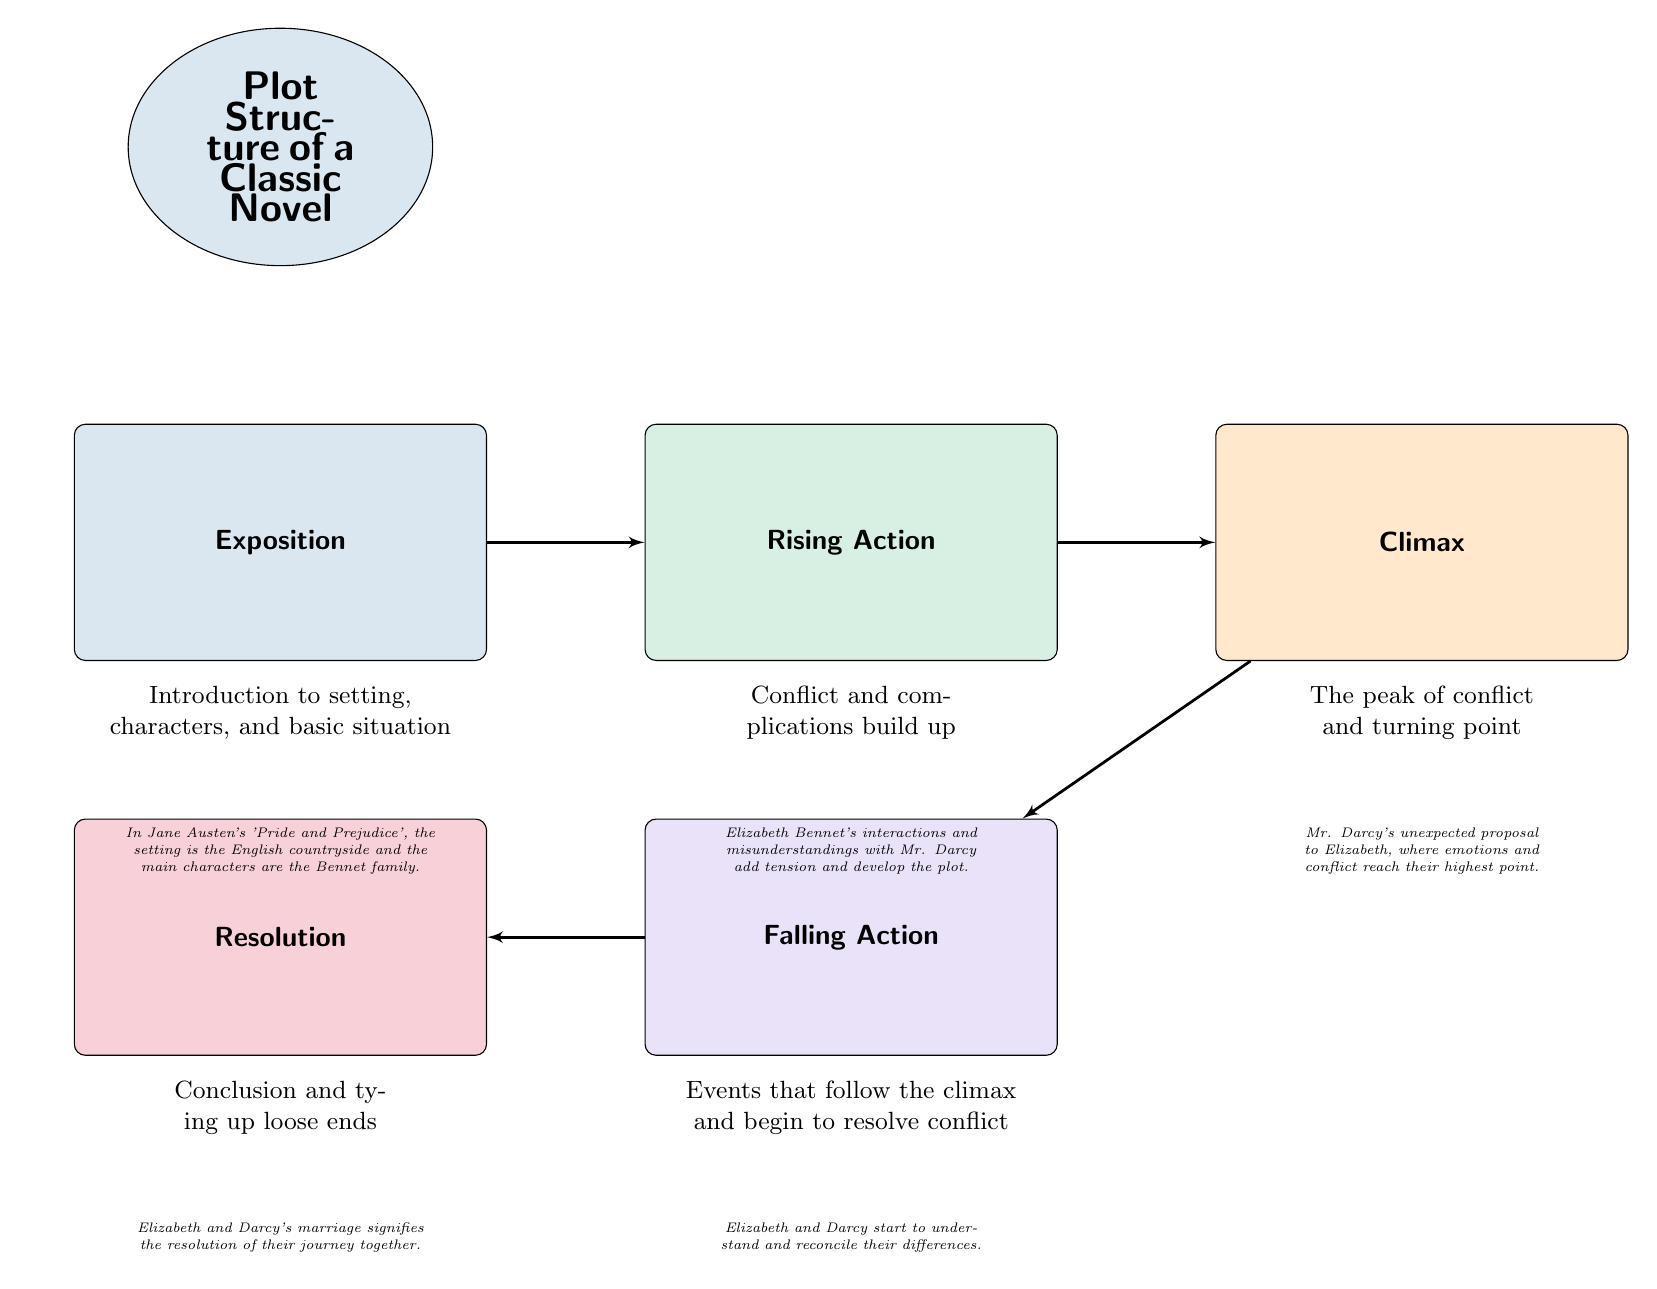What is the first element in the plot structure? The first element in the plot structure is identified as "Exposition," which is located at the top of the diagram.
Answer: Exposition How many main elements are in the plot structure? The diagram lists five main elements: Exposition, Rising Action, Climax, Falling Action, and Resolution. This can be counted directly from the blocks in the diagram.
Answer: Five What follows the Climax in the plot structure? According to the diagram, "Falling Action" is presented directly below "Climax," indicating it follows next in the sequence of the plot structure.
Answer: Falling Action What is the purpose of the Exposition? The Exposition serves to introduce the setting, characters, and basic situation, as stated directly below the corresponding block in the diagram.
Answer: Introduction to setting, characters, and basic situation What is the relationship between Rising Action and Resolution in the diagram? There is a downward connection from "Rising Action" leading to "Climax," and from "Climax," it continues downward to "Falling Action," which then points left to "Resolution," indicating a flow from Rising Action through to Resolution.
Answer: They are connected through Climax and Falling Action What is the peak of conflict referred to in the diagram? The peak of conflict is referred to as "Climax," which is specifically defined as the point where conflict reaches its highest intensity.
Answer: Climax Which element represents the conclusion in the plot structure? "Resolution" is the element that represents the conclusion of the story, as indicated by its location at the end of the plot structure and the description provided below it.
Answer: Resolution What is described in the Falling Action section of the diagram? The Falling Action section describes events that follow the climax and begin to resolve conflict, which is directly stated in the text beneath that block.
Answer: Events that follow the climax and begin to resolve conflict What example illustrates the Exposition? The example provided for the Exposition is from Jane Austen's 'Pride and Prejudice', where the setting is the English countryside and the main characters are the Bennet family.
Answer: In Jane Austen's 'Pride and Prejudice', the setting is the English countryside and the main characters are the Bennet family 